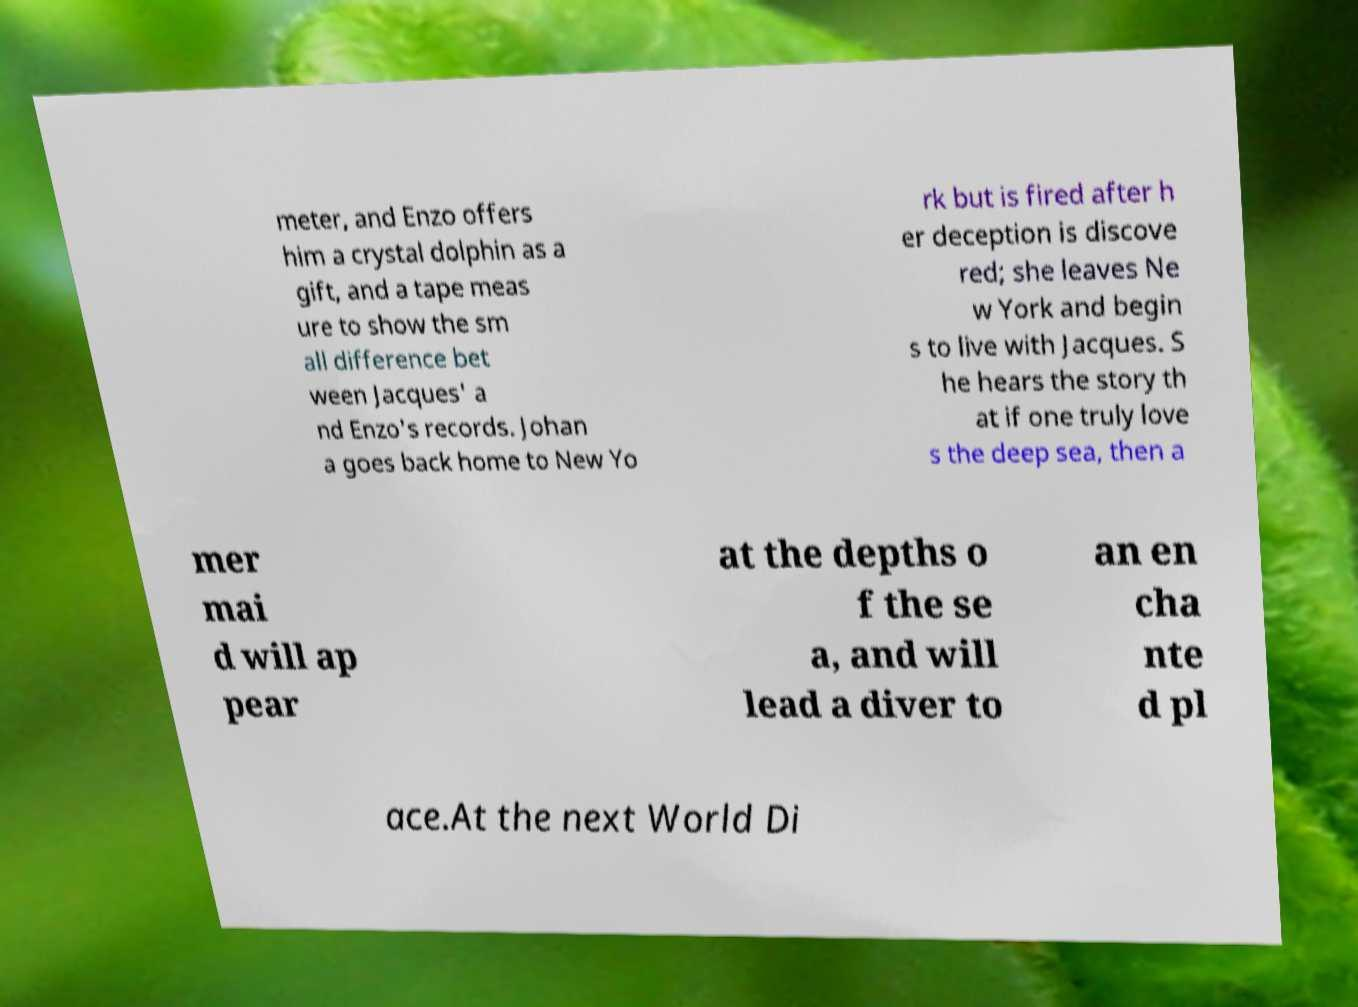Please read and relay the text visible in this image. What does it say? meter, and Enzo offers him a crystal dolphin as a gift, and a tape meas ure to show the sm all difference bet ween Jacques' a nd Enzo's records. Johan a goes back home to New Yo rk but is fired after h er deception is discove red; she leaves Ne w York and begin s to live with Jacques. S he hears the story th at if one truly love s the deep sea, then a mer mai d will ap pear at the depths o f the se a, and will lead a diver to an en cha nte d pl ace.At the next World Di 